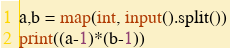<code> <loc_0><loc_0><loc_500><loc_500><_Python_>a,b = map(int, input().split())
print((a-1)*(b-1))
</code> 